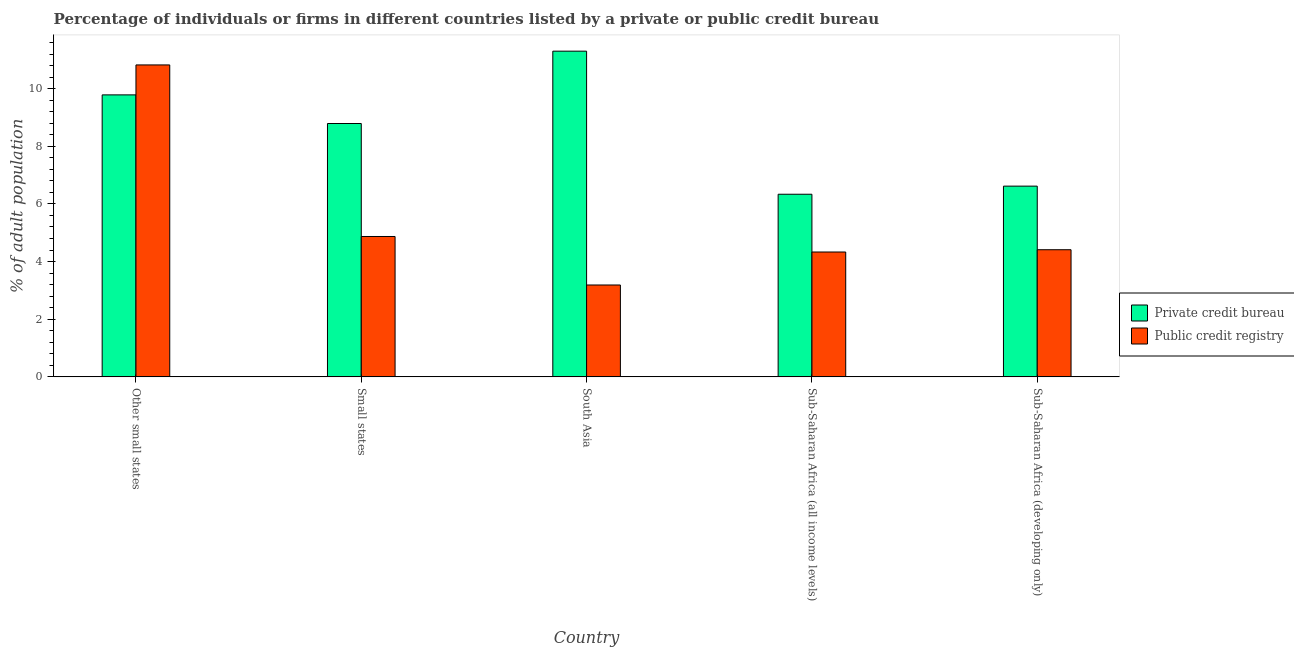How many different coloured bars are there?
Offer a very short reply. 2. Are the number of bars per tick equal to the number of legend labels?
Your response must be concise. Yes. How many bars are there on the 4th tick from the right?
Keep it short and to the point. 2. What is the label of the 1st group of bars from the left?
Make the answer very short. Other small states. In how many cases, is the number of bars for a given country not equal to the number of legend labels?
Ensure brevity in your answer.  0. What is the percentage of firms listed by public credit bureau in Sub-Saharan Africa (all income levels)?
Ensure brevity in your answer.  4.33. Across all countries, what is the maximum percentage of firms listed by public credit bureau?
Your response must be concise. 10.82. Across all countries, what is the minimum percentage of firms listed by private credit bureau?
Make the answer very short. 6.34. In which country was the percentage of firms listed by public credit bureau maximum?
Offer a very short reply. Other small states. In which country was the percentage of firms listed by private credit bureau minimum?
Keep it short and to the point. Sub-Saharan Africa (all income levels). What is the total percentage of firms listed by public credit bureau in the graph?
Make the answer very short. 27.62. What is the difference between the percentage of firms listed by public credit bureau in Other small states and that in South Asia?
Provide a short and direct response. 7.63. What is the difference between the percentage of firms listed by private credit bureau in Small states and the percentage of firms listed by public credit bureau in Other small states?
Offer a very short reply. -2.03. What is the average percentage of firms listed by public credit bureau per country?
Provide a succinct answer. 5.52. What is the difference between the percentage of firms listed by public credit bureau and percentage of firms listed by private credit bureau in Small states?
Offer a terse response. -3.92. In how many countries, is the percentage of firms listed by public credit bureau greater than 2 %?
Give a very brief answer. 5. What is the ratio of the percentage of firms listed by public credit bureau in Small states to that in Sub-Saharan Africa (developing only)?
Offer a very short reply. 1.1. Is the percentage of firms listed by public credit bureau in Small states less than that in South Asia?
Your answer should be compact. No. Is the difference between the percentage of firms listed by public credit bureau in Other small states and Sub-Saharan Africa (all income levels) greater than the difference between the percentage of firms listed by private credit bureau in Other small states and Sub-Saharan Africa (all income levels)?
Your answer should be compact. Yes. What is the difference between the highest and the second highest percentage of firms listed by private credit bureau?
Give a very brief answer. 1.52. What is the difference between the highest and the lowest percentage of firms listed by private credit bureau?
Give a very brief answer. 4.96. Is the sum of the percentage of firms listed by private credit bureau in Other small states and Sub-Saharan Africa (all income levels) greater than the maximum percentage of firms listed by public credit bureau across all countries?
Give a very brief answer. Yes. What does the 2nd bar from the left in South Asia represents?
Provide a succinct answer. Public credit registry. What does the 2nd bar from the right in Other small states represents?
Ensure brevity in your answer.  Private credit bureau. What is the difference between two consecutive major ticks on the Y-axis?
Keep it short and to the point. 2. Does the graph contain any zero values?
Your answer should be compact. No. How many legend labels are there?
Make the answer very short. 2. What is the title of the graph?
Offer a very short reply. Percentage of individuals or firms in different countries listed by a private or public credit bureau. What is the label or title of the X-axis?
Provide a short and direct response. Country. What is the label or title of the Y-axis?
Make the answer very short. % of adult population. What is the % of adult population in Private credit bureau in Other small states?
Provide a short and direct response. 9.78. What is the % of adult population in Public credit registry in Other small states?
Keep it short and to the point. 10.82. What is the % of adult population of Private credit bureau in Small states?
Your response must be concise. 8.79. What is the % of adult population in Public credit registry in Small states?
Offer a terse response. 4.87. What is the % of adult population of Private credit bureau in South Asia?
Ensure brevity in your answer.  11.3. What is the % of adult population of Public credit registry in South Asia?
Your answer should be very brief. 3.19. What is the % of adult population in Private credit bureau in Sub-Saharan Africa (all income levels)?
Give a very brief answer. 6.34. What is the % of adult population of Public credit registry in Sub-Saharan Africa (all income levels)?
Your response must be concise. 4.33. What is the % of adult population of Private credit bureau in Sub-Saharan Africa (developing only)?
Your answer should be compact. 6.62. What is the % of adult population in Public credit registry in Sub-Saharan Africa (developing only)?
Your answer should be very brief. 4.41. Across all countries, what is the maximum % of adult population of Public credit registry?
Your answer should be very brief. 10.82. Across all countries, what is the minimum % of adult population of Private credit bureau?
Make the answer very short. 6.34. Across all countries, what is the minimum % of adult population of Public credit registry?
Make the answer very short. 3.19. What is the total % of adult population in Private credit bureau in the graph?
Your response must be concise. 42.83. What is the total % of adult population in Public credit registry in the graph?
Your answer should be compact. 27.62. What is the difference between the % of adult population in Public credit registry in Other small states and that in Small states?
Your response must be concise. 5.95. What is the difference between the % of adult population of Private credit bureau in Other small states and that in South Asia?
Offer a very short reply. -1.52. What is the difference between the % of adult population in Public credit registry in Other small states and that in South Asia?
Offer a very short reply. 7.63. What is the difference between the % of adult population in Private credit bureau in Other small states and that in Sub-Saharan Africa (all income levels)?
Offer a very short reply. 3.45. What is the difference between the % of adult population of Public credit registry in Other small states and that in Sub-Saharan Africa (all income levels)?
Provide a short and direct response. 6.49. What is the difference between the % of adult population in Private credit bureau in Other small states and that in Sub-Saharan Africa (developing only)?
Make the answer very short. 3.17. What is the difference between the % of adult population of Public credit registry in Other small states and that in Sub-Saharan Africa (developing only)?
Ensure brevity in your answer.  6.41. What is the difference between the % of adult population of Private credit bureau in Small states and that in South Asia?
Provide a succinct answer. -2.51. What is the difference between the % of adult population of Public credit registry in Small states and that in South Asia?
Your answer should be very brief. 1.68. What is the difference between the % of adult population of Private credit bureau in Small states and that in Sub-Saharan Africa (all income levels)?
Offer a terse response. 2.45. What is the difference between the % of adult population in Public credit registry in Small states and that in Sub-Saharan Africa (all income levels)?
Make the answer very short. 0.54. What is the difference between the % of adult population in Private credit bureau in Small states and that in Sub-Saharan Africa (developing only)?
Keep it short and to the point. 2.17. What is the difference between the % of adult population in Public credit registry in Small states and that in Sub-Saharan Africa (developing only)?
Offer a very short reply. 0.46. What is the difference between the % of adult population of Private credit bureau in South Asia and that in Sub-Saharan Africa (all income levels)?
Your answer should be very brief. 4.96. What is the difference between the % of adult population of Public credit registry in South Asia and that in Sub-Saharan Africa (all income levels)?
Provide a succinct answer. -1.14. What is the difference between the % of adult population in Private credit bureau in South Asia and that in Sub-Saharan Africa (developing only)?
Your answer should be very brief. 4.68. What is the difference between the % of adult population of Public credit registry in South Asia and that in Sub-Saharan Africa (developing only)?
Your answer should be very brief. -1.22. What is the difference between the % of adult population of Private credit bureau in Sub-Saharan Africa (all income levels) and that in Sub-Saharan Africa (developing only)?
Keep it short and to the point. -0.28. What is the difference between the % of adult population in Public credit registry in Sub-Saharan Africa (all income levels) and that in Sub-Saharan Africa (developing only)?
Your answer should be very brief. -0.08. What is the difference between the % of adult population in Private credit bureau in Other small states and the % of adult population in Public credit registry in Small states?
Make the answer very short. 4.91. What is the difference between the % of adult population in Private credit bureau in Other small states and the % of adult population in Public credit registry in South Asia?
Offer a very short reply. 6.6. What is the difference between the % of adult population in Private credit bureau in Other small states and the % of adult population in Public credit registry in Sub-Saharan Africa (all income levels)?
Give a very brief answer. 5.45. What is the difference between the % of adult population in Private credit bureau in Other small states and the % of adult population in Public credit registry in Sub-Saharan Africa (developing only)?
Offer a very short reply. 5.37. What is the difference between the % of adult population in Private credit bureau in Small states and the % of adult population in Public credit registry in South Asia?
Offer a terse response. 5.6. What is the difference between the % of adult population in Private credit bureau in Small states and the % of adult population in Public credit registry in Sub-Saharan Africa (all income levels)?
Your answer should be very brief. 4.46. What is the difference between the % of adult population in Private credit bureau in Small states and the % of adult population in Public credit registry in Sub-Saharan Africa (developing only)?
Your answer should be very brief. 4.38. What is the difference between the % of adult population of Private credit bureau in South Asia and the % of adult population of Public credit registry in Sub-Saharan Africa (all income levels)?
Offer a very short reply. 6.97. What is the difference between the % of adult population in Private credit bureau in South Asia and the % of adult population in Public credit registry in Sub-Saharan Africa (developing only)?
Offer a terse response. 6.89. What is the difference between the % of adult population of Private credit bureau in Sub-Saharan Africa (all income levels) and the % of adult population of Public credit registry in Sub-Saharan Africa (developing only)?
Ensure brevity in your answer.  1.92. What is the average % of adult population of Private credit bureau per country?
Your answer should be very brief. 8.57. What is the average % of adult population in Public credit registry per country?
Provide a short and direct response. 5.52. What is the difference between the % of adult population in Private credit bureau and % of adult population in Public credit registry in Other small states?
Provide a short and direct response. -1.04. What is the difference between the % of adult population of Private credit bureau and % of adult population of Public credit registry in Small states?
Make the answer very short. 3.92. What is the difference between the % of adult population of Private credit bureau and % of adult population of Public credit registry in South Asia?
Provide a succinct answer. 8.11. What is the difference between the % of adult population of Private credit bureau and % of adult population of Public credit registry in Sub-Saharan Africa (all income levels)?
Provide a short and direct response. 2. What is the difference between the % of adult population of Private credit bureau and % of adult population of Public credit registry in Sub-Saharan Africa (developing only)?
Offer a terse response. 2.21. What is the ratio of the % of adult population of Private credit bureau in Other small states to that in Small states?
Offer a terse response. 1.11. What is the ratio of the % of adult population of Public credit registry in Other small states to that in Small states?
Make the answer very short. 2.22. What is the ratio of the % of adult population of Private credit bureau in Other small states to that in South Asia?
Make the answer very short. 0.87. What is the ratio of the % of adult population of Public credit registry in Other small states to that in South Asia?
Keep it short and to the point. 3.4. What is the ratio of the % of adult population of Private credit bureau in Other small states to that in Sub-Saharan Africa (all income levels)?
Ensure brevity in your answer.  1.54. What is the ratio of the % of adult population in Public credit registry in Other small states to that in Sub-Saharan Africa (all income levels)?
Your answer should be very brief. 2.5. What is the ratio of the % of adult population of Private credit bureau in Other small states to that in Sub-Saharan Africa (developing only)?
Give a very brief answer. 1.48. What is the ratio of the % of adult population in Public credit registry in Other small states to that in Sub-Saharan Africa (developing only)?
Ensure brevity in your answer.  2.45. What is the ratio of the % of adult population of Private credit bureau in Small states to that in South Asia?
Your answer should be compact. 0.78. What is the ratio of the % of adult population in Public credit registry in Small states to that in South Asia?
Make the answer very short. 1.53. What is the ratio of the % of adult population in Private credit bureau in Small states to that in Sub-Saharan Africa (all income levels)?
Your answer should be compact. 1.39. What is the ratio of the % of adult population of Public credit registry in Small states to that in Sub-Saharan Africa (all income levels)?
Ensure brevity in your answer.  1.12. What is the ratio of the % of adult population of Private credit bureau in Small states to that in Sub-Saharan Africa (developing only)?
Offer a very short reply. 1.33. What is the ratio of the % of adult population of Public credit registry in Small states to that in Sub-Saharan Africa (developing only)?
Make the answer very short. 1.1. What is the ratio of the % of adult population of Private credit bureau in South Asia to that in Sub-Saharan Africa (all income levels)?
Your answer should be very brief. 1.78. What is the ratio of the % of adult population in Public credit registry in South Asia to that in Sub-Saharan Africa (all income levels)?
Offer a very short reply. 0.74. What is the ratio of the % of adult population of Private credit bureau in South Asia to that in Sub-Saharan Africa (developing only)?
Give a very brief answer. 1.71. What is the ratio of the % of adult population of Public credit registry in South Asia to that in Sub-Saharan Africa (developing only)?
Ensure brevity in your answer.  0.72. What is the ratio of the % of adult population of Private credit bureau in Sub-Saharan Africa (all income levels) to that in Sub-Saharan Africa (developing only)?
Your response must be concise. 0.96. What is the ratio of the % of adult population of Public credit registry in Sub-Saharan Africa (all income levels) to that in Sub-Saharan Africa (developing only)?
Give a very brief answer. 0.98. What is the difference between the highest and the second highest % of adult population of Private credit bureau?
Keep it short and to the point. 1.52. What is the difference between the highest and the second highest % of adult population in Public credit registry?
Your answer should be very brief. 5.95. What is the difference between the highest and the lowest % of adult population of Private credit bureau?
Make the answer very short. 4.96. What is the difference between the highest and the lowest % of adult population of Public credit registry?
Provide a short and direct response. 7.63. 